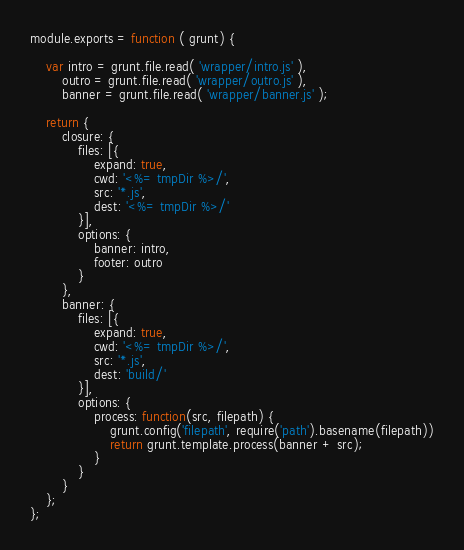<code> <loc_0><loc_0><loc_500><loc_500><_JavaScript_>module.exports = function ( grunt) {

	var intro = grunt.file.read( 'wrapper/intro.js' ),
		outro = grunt.file.read( 'wrapper/outro.js' ),
		banner = grunt.file.read( 'wrapper/banner.js' );

	return {
		closure: {
			files: [{
				expand: true,
				cwd: '<%= tmpDir %>/',
				src: '*.js',
				dest: '<%= tmpDir %>/'
			}],
			options: {
				banner: intro,
				footer: outro
			}
		},
		banner: {
			files: [{
				expand: true,
				cwd: '<%= tmpDir %>/',
				src: '*.js',
				dest: 'build/'
			}],
			options: {
				process: function(src, filepath) {
		        	grunt.config('filepath', require('path').basename(filepath))
		        	return grunt.template.process(banner + src);
		        }
			}
		}
	};
};
</code> 